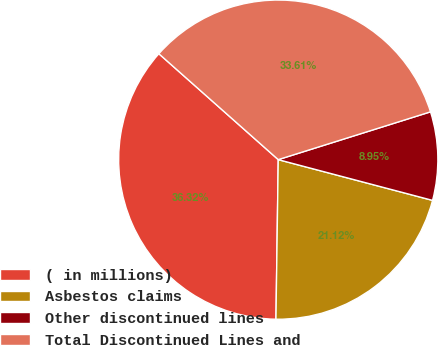<chart> <loc_0><loc_0><loc_500><loc_500><pie_chart><fcel>( in millions)<fcel>Asbestos claims<fcel>Other discontinued lines<fcel>Total Discontinued Lines and<nl><fcel>36.32%<fcel>21.12%<fcel>8.95%<fcel>33.61%<nl></chart> 